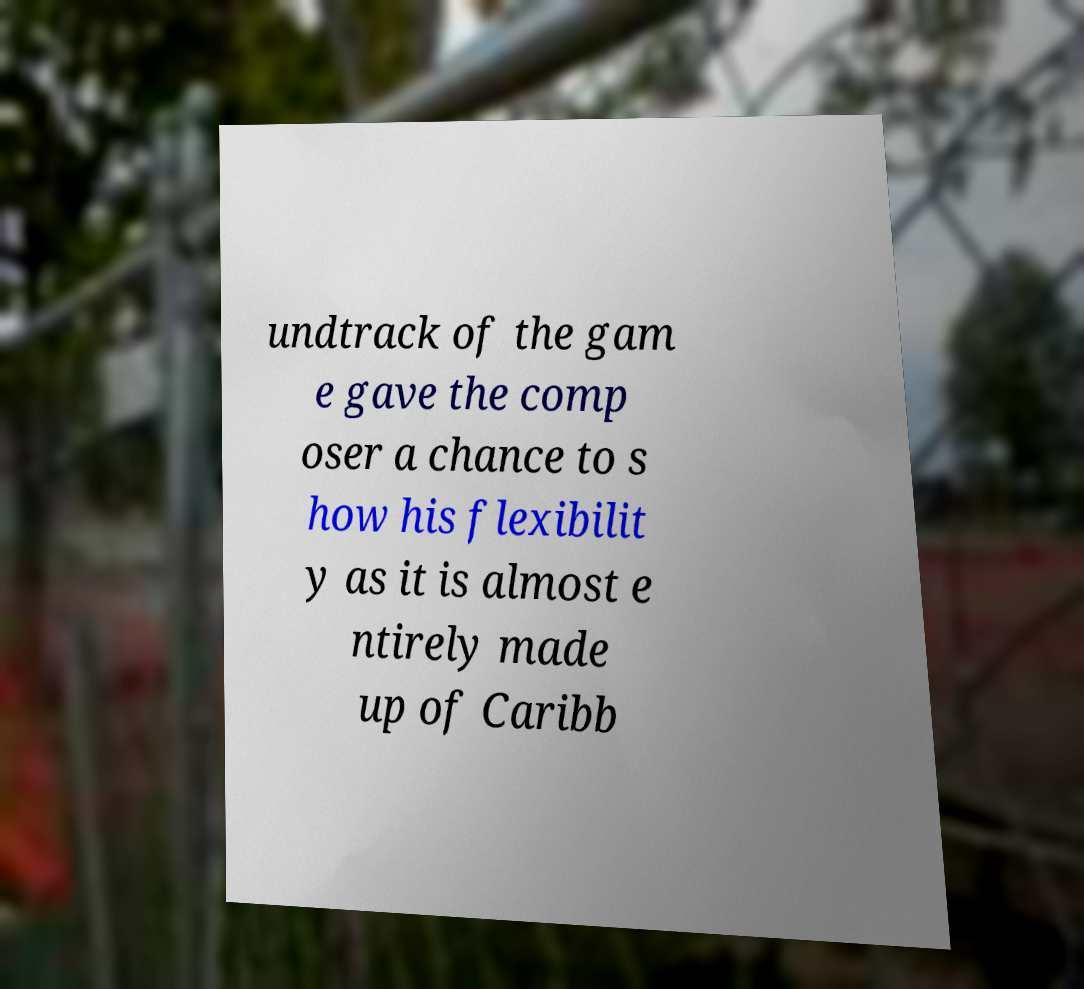Can you read and provide the text displayed in the image?This photo seems to have some interesting text. Can you extract and type it out for me? undtrack of the gam e gave the comp oser a chance to s how his flexibilit y as it is almost e ntirely made up of Caribb 